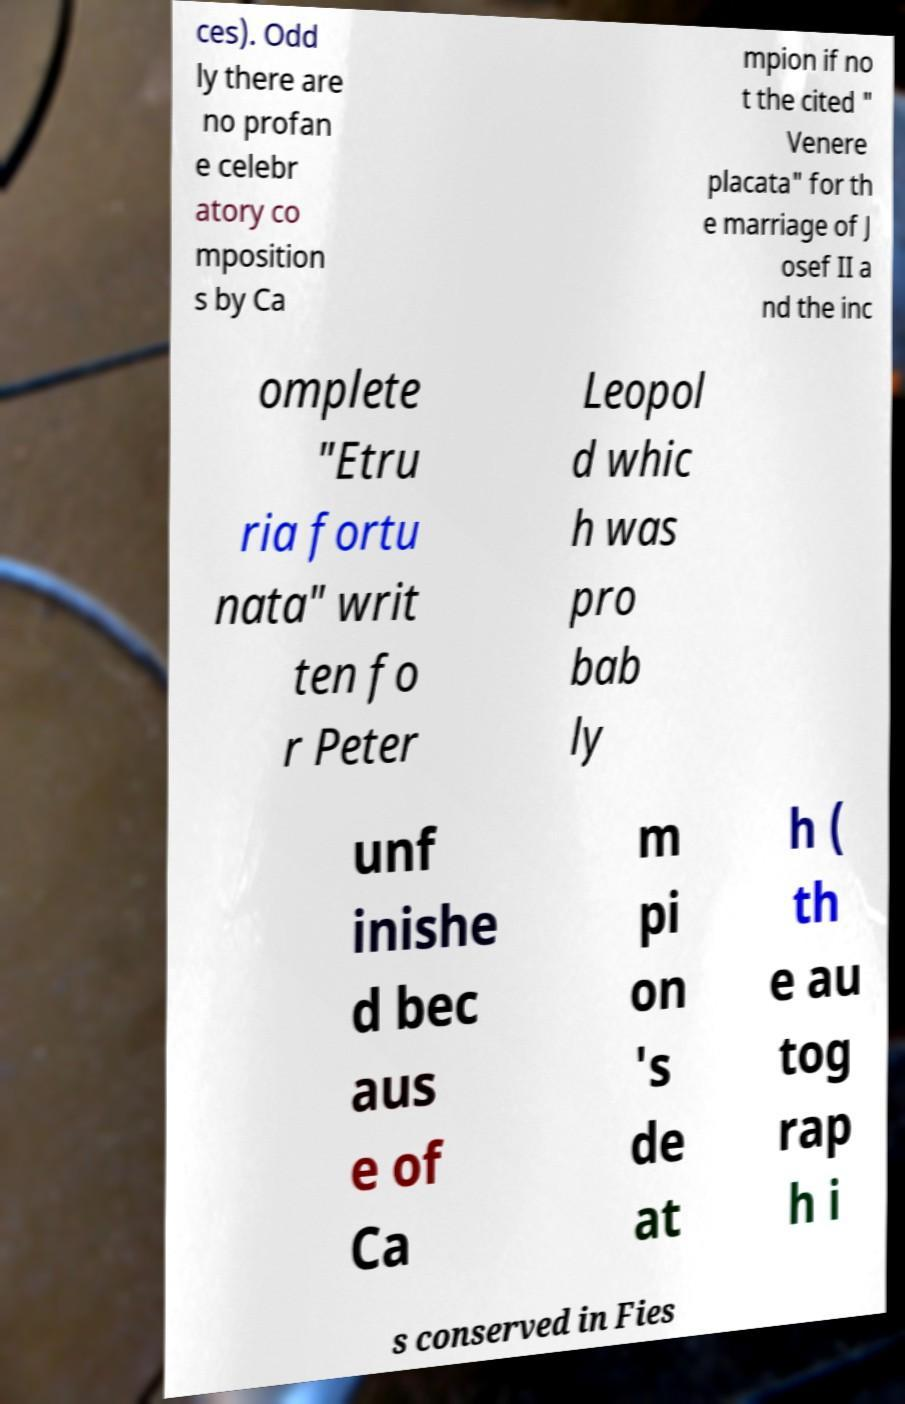Please read and relay the text visible in this image. What does it say? ces). Odd ly there are no profan e celebr atory co mposition s by Ca mpion if no t the cited " Venere placata" for th e marriage of J osef II a nd the inc omplete "Etru ria fortu nata" writ ten fo r Peter Leopol d whic h was pro bab ly unf inishe d bec aus e of Ca m pi on 's de at h ( th e au tog rap h i s conserved in Fies 